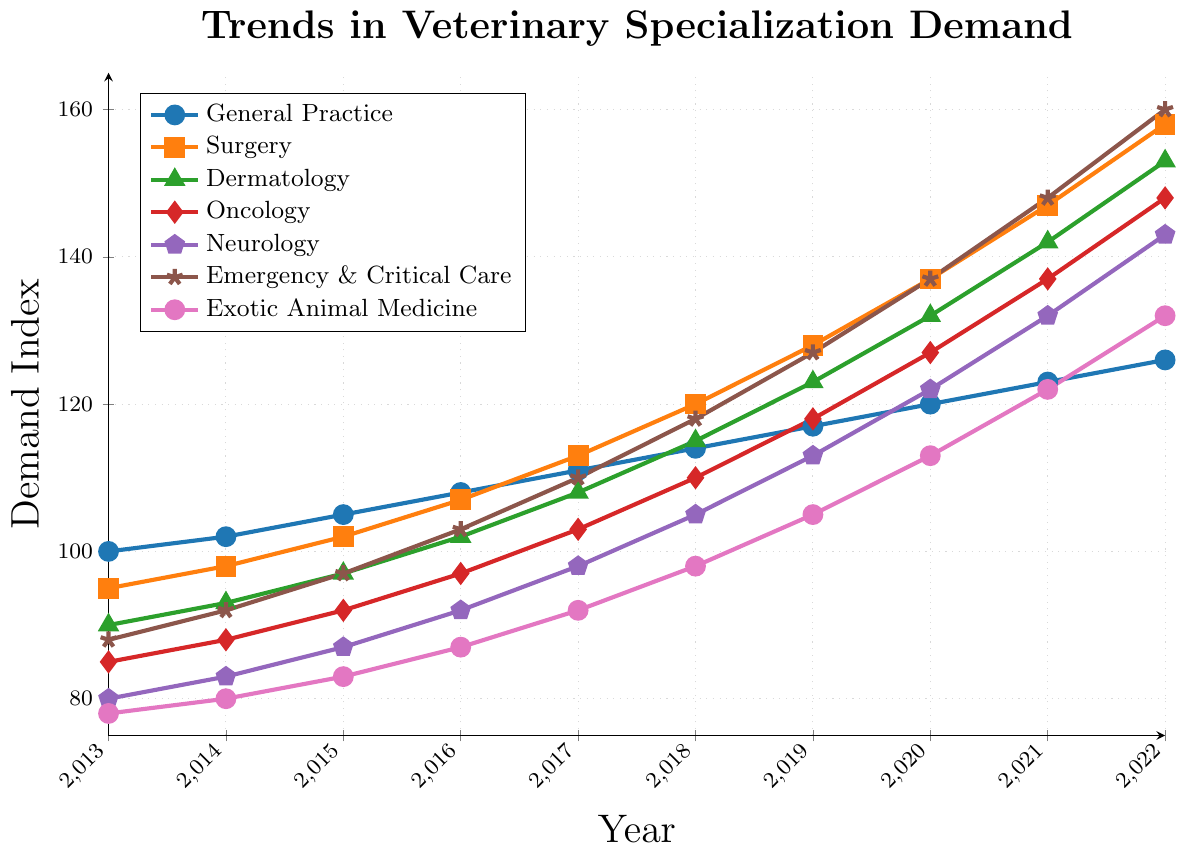What field has shown the highest demand growth from 2013 to 2022? By looking at the trend lines and comparing the start and end values, Surgery shows the most significant increase from 95 in 2013 to 158 in 2022, which is an increase of 63 points.
Answer: Surgery Which specialization had the lowest demand in 2013 and how does it compare to its 2022 demand? Exotic Animal Medicine had the lowest demand in 2013 with a value of 78. In 2022, its demand increased to 132, showing an increase of 54 points.
Answer: Exotic Animal Medicine, increase of 54 By what percentage did the demand for Oncology increase between 2013 and 2022? The demand for Oncology increased from 85 in 2013 to 148 in 2022. The percentage increase is calculated as ((148 - 85) / 85) * 100, which equals approximately 74.1%.
Answer: Approximately 74.1% Between 2016 and 2020, which field saw the steepest growth in demand? Looking at the slopes of the trend lines between 2016 and 2020, Surgery shows the steepest growth, increasing from 107 to 137, which is a difference of 30 points.
Answer: Surgery Which specialization had the most consistent growth over the years? General Practice shows the most consistent growth with a steady increase each year from 100 in 2013 to 126 in 2022, without any dramatic jumps or declines.
Answer: General Practice How does the demand in 2019 for Exotic Animal Medicine compare to Neurology? In 2019, Exotic Animal Medicine had a demand of 105, while Neurology had a demand of 113. Therefore, Neurology had a higher demand by 8 points.
Answer: Neurology was higher by 8 points What is the average demand for Dermatology between 2013 and 2022? Adding the demand values for Dermatology each year (90, 93, 97, 102, 108, 115, 123, 132, 142, 153) gives a total of 1155. Dividing by the number of years (10) gives an average of 115.5.
Answer: 115.5 Compare the demand increase for Emergency & Critical Care from 2013 to 2022 with that of Neurology in the same period. Emergency & Critical Care increased from 88 in 2013 to 160 in 2022 (72 points increase). Neurology increased from 80 in 2013 to 143 in 2022 (63 points increase). Emergency & Critical Care had a higher increase.
Answer: Emergency & Critical Care had an increase of 72 points, Neurology had an increase of 63 points 